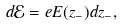<formula> <loc_0><loc_0><loc_500><loc_500>d { \mathcal { E } } = e E ( z _ { - } ) d z _ { - } ,</formula> 